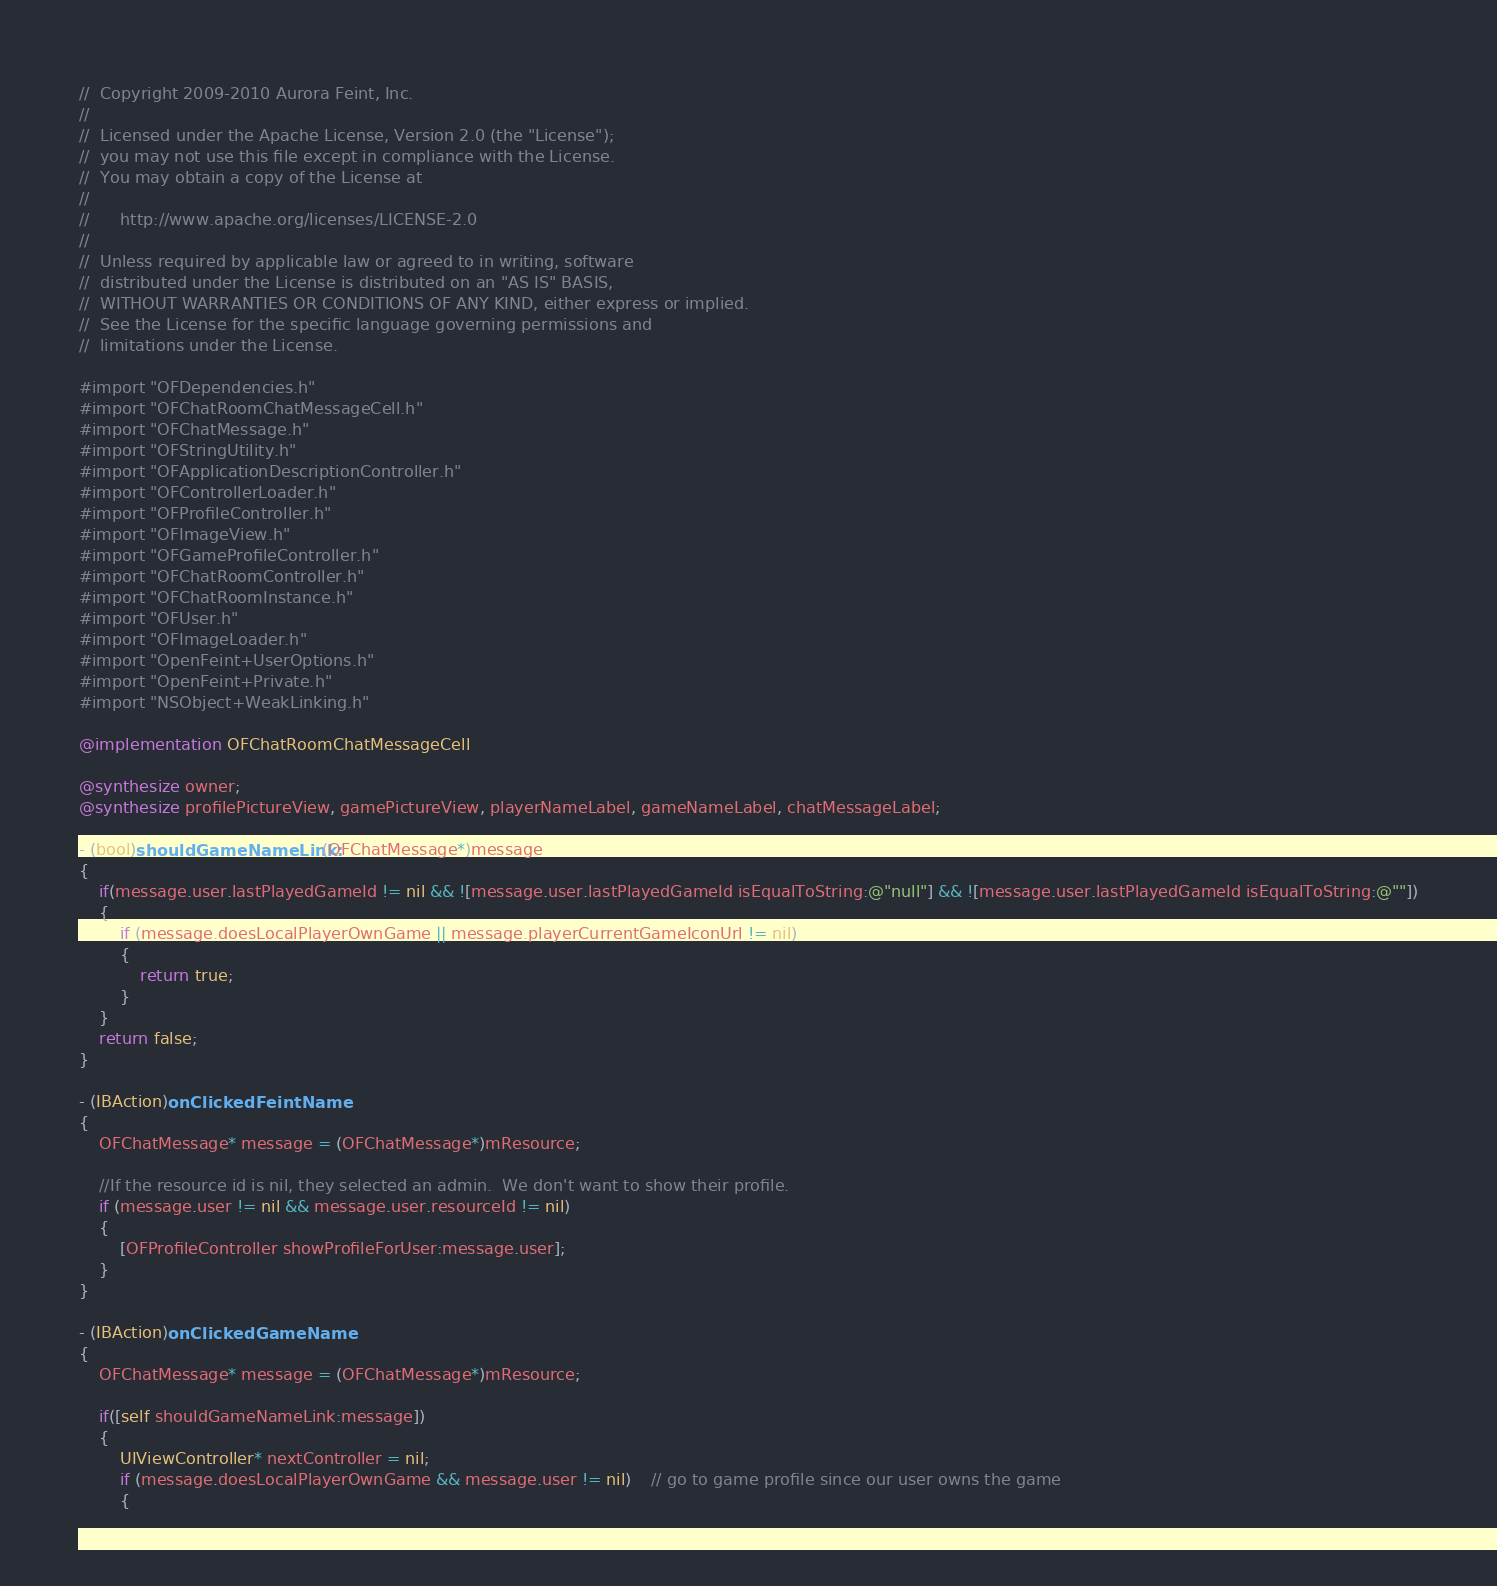Convert code to text. <code><loc_0><loc_0><loc_500><loc_500><_ObjectiveC_>//  Copyright 2009-2010 Aurora Feint, Inc.
// 
//  Licensed under the Apache License, Version 2.0 (the "License");
//  you may not use this file except in compliance with the License.
//  You may obtain a copy of the License at
//  
//  	http://www.apache.org/licenses/LICENSE-2.0
//  	
//  Unless required by applicable law or agreed to in writing, software
//  distributed under the License is distributed on an "AS IS" BASIS,
//  WITHOUT WARRANTIES OR CONDITIONS OF ANY KIND, either express or implied.
//  See the License for the specific language governing permissions and
//  limitations under the License.

#import "OFDependencies.h"
#import "OFChatRoomChatMessageCell.h"
#import "OFChatMessage.h"
#import "OFStringUtility.h"
#import "OFApplicationDescriptionController.h"
#import "OFControllerLoader.h"
#import "OFProfileController.h"
#import "OFImageView.h"
#import "OFGameProfileController.h"
#import "OFChatRoomController.h"
#import "OFChatRoomInstance.h"
#import "OFUser.h"
#import "OFImageLoader.h"
#import "OpenFeint+UserOptions.h"
#import "OpenFeint+Private.h"
#import "NSObject+WeakLinking.h"

@implementation OFChatRoomChatMessageCell

@synthesize owner;
@synthesize profilePictureView, gamePictureView, playerNameLabel, gameNameLabel, chatMessageLabel;

- (bool)shouldGameNameLink:(OFChatMessage*)message
{
	if(message.user.lastPlayedGameId != nil && ![message.user.lastPlayedGameId isEqualToString:@"null"] && ![message.user.lastPlayedGameId isEqualToString:@""])
	{
		if (message.doesLocalPlayerOwnGame || message.playerCurrentGameIconUrl != nil)
		{
			return true;
		}
	}
	return false;
}

- (IBAction)onClickedFeintName
{
	OFChatMessage* message = (OFChatMessage*)mResource;
	
	//If the resource id is nil, they selected an admin.  We don't want to show their profile.
	if (message.user != nil && message.user.resourceId != nil)
	{
		[OFProfileController showProfileForUser:message.user];
	}
}

- (IBAction)onClickedGameName
{
	OFChatMessage* message = (OFChatMessage*)mResource;

	if([self shouldGameNameLink:message])
	{
		UIViewController* nextController = nil;
		if (message.doesLocalPlayerOwnGame && message.user != nil)	// go to game profile since our user owns the game
		{</code> 